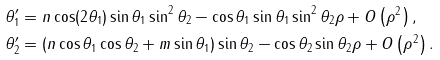<formula> <loc_0><loc_0><loc_500><loc_500>& \theta _ { 1 } ^ { \prime } = n \cos ( 2 \theta _ { 1 } ) \sin \theta _ { 1 } \sin ^ { 2 } \theta _ { 2 } - \cos \theta _ { 1 } \sin \theta _ { 1 } \sin ^ { 2 } \theta _ { 2 } \rho + O \left ( \rho ^ { 2 } \right ) , \\ & \theta _ { 2 } ^ { \prime } = ( n \cos \theta _ { 1 } \cos \theta _ { 2 } + m \sin \theta _ { 1 } ) \sin \theta _ { 2 } - \cos \theta _ { 2 } \sin \theta _ { 2 } \rho + O \left ( \rho ^ { 2 } \right ) .</formula> 